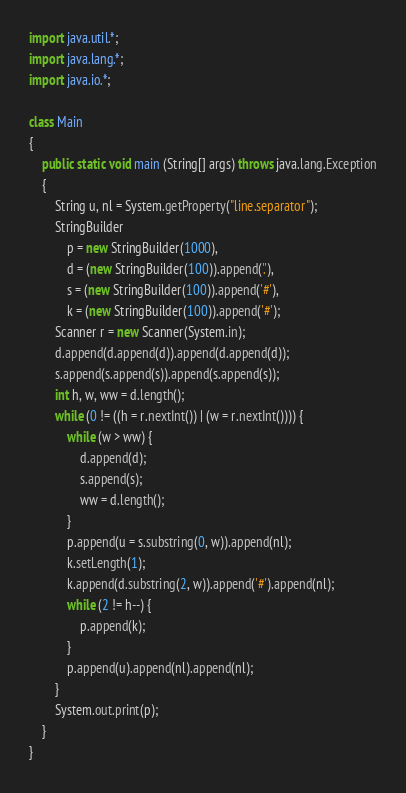Convert code to text. <code><loc_0><loc_0><loc_500><loc_500><_Java_>import java.util.*;
import java.lang.*;
import java.io.*;
 
class Main
{
    public static void main (String[] args) throws java.lang.Exception
    {
        String u, nl = System.getProperty("line.separator");
        StringBuilder
            p = new StringBuilder(1000),
            d = (new StringBuilder(100)).append('.'),
            s = (new StringBuilder(100)).append('#'),
            k = (new StringBuilder(100)).append('#');
        Scanner r = new Scanner(System.in);
        d.append(d.append(d)).append(d.append(d));
        s.append(s.append(s)).append(s.append(s));
        int h, w, ww = d.length();
        while (0 != ((h = r.nextInt()) | (w = r.nextInt()))) {
            while (w > ww) {
                d.append(d);
                s.append(s);
                ww = d.length();
            }
            p.append(u = s.substring(0, w)).append(nl);
            k.setLength(1);
            k.append(d.substring(2, w)).append('#').append(nl);
            while (2 != h--) {
                p.append(k);
            }
            p.append(u).append(nl).append(nl);
        }
        System.out.print(p);
    }
}</code> 